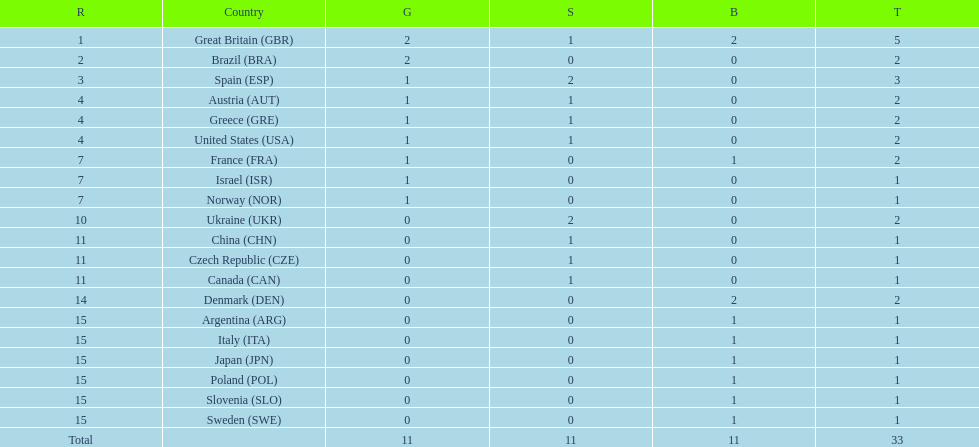Who won more gold medals than spain? Great Britain (GBR), Brazil (BRA). 